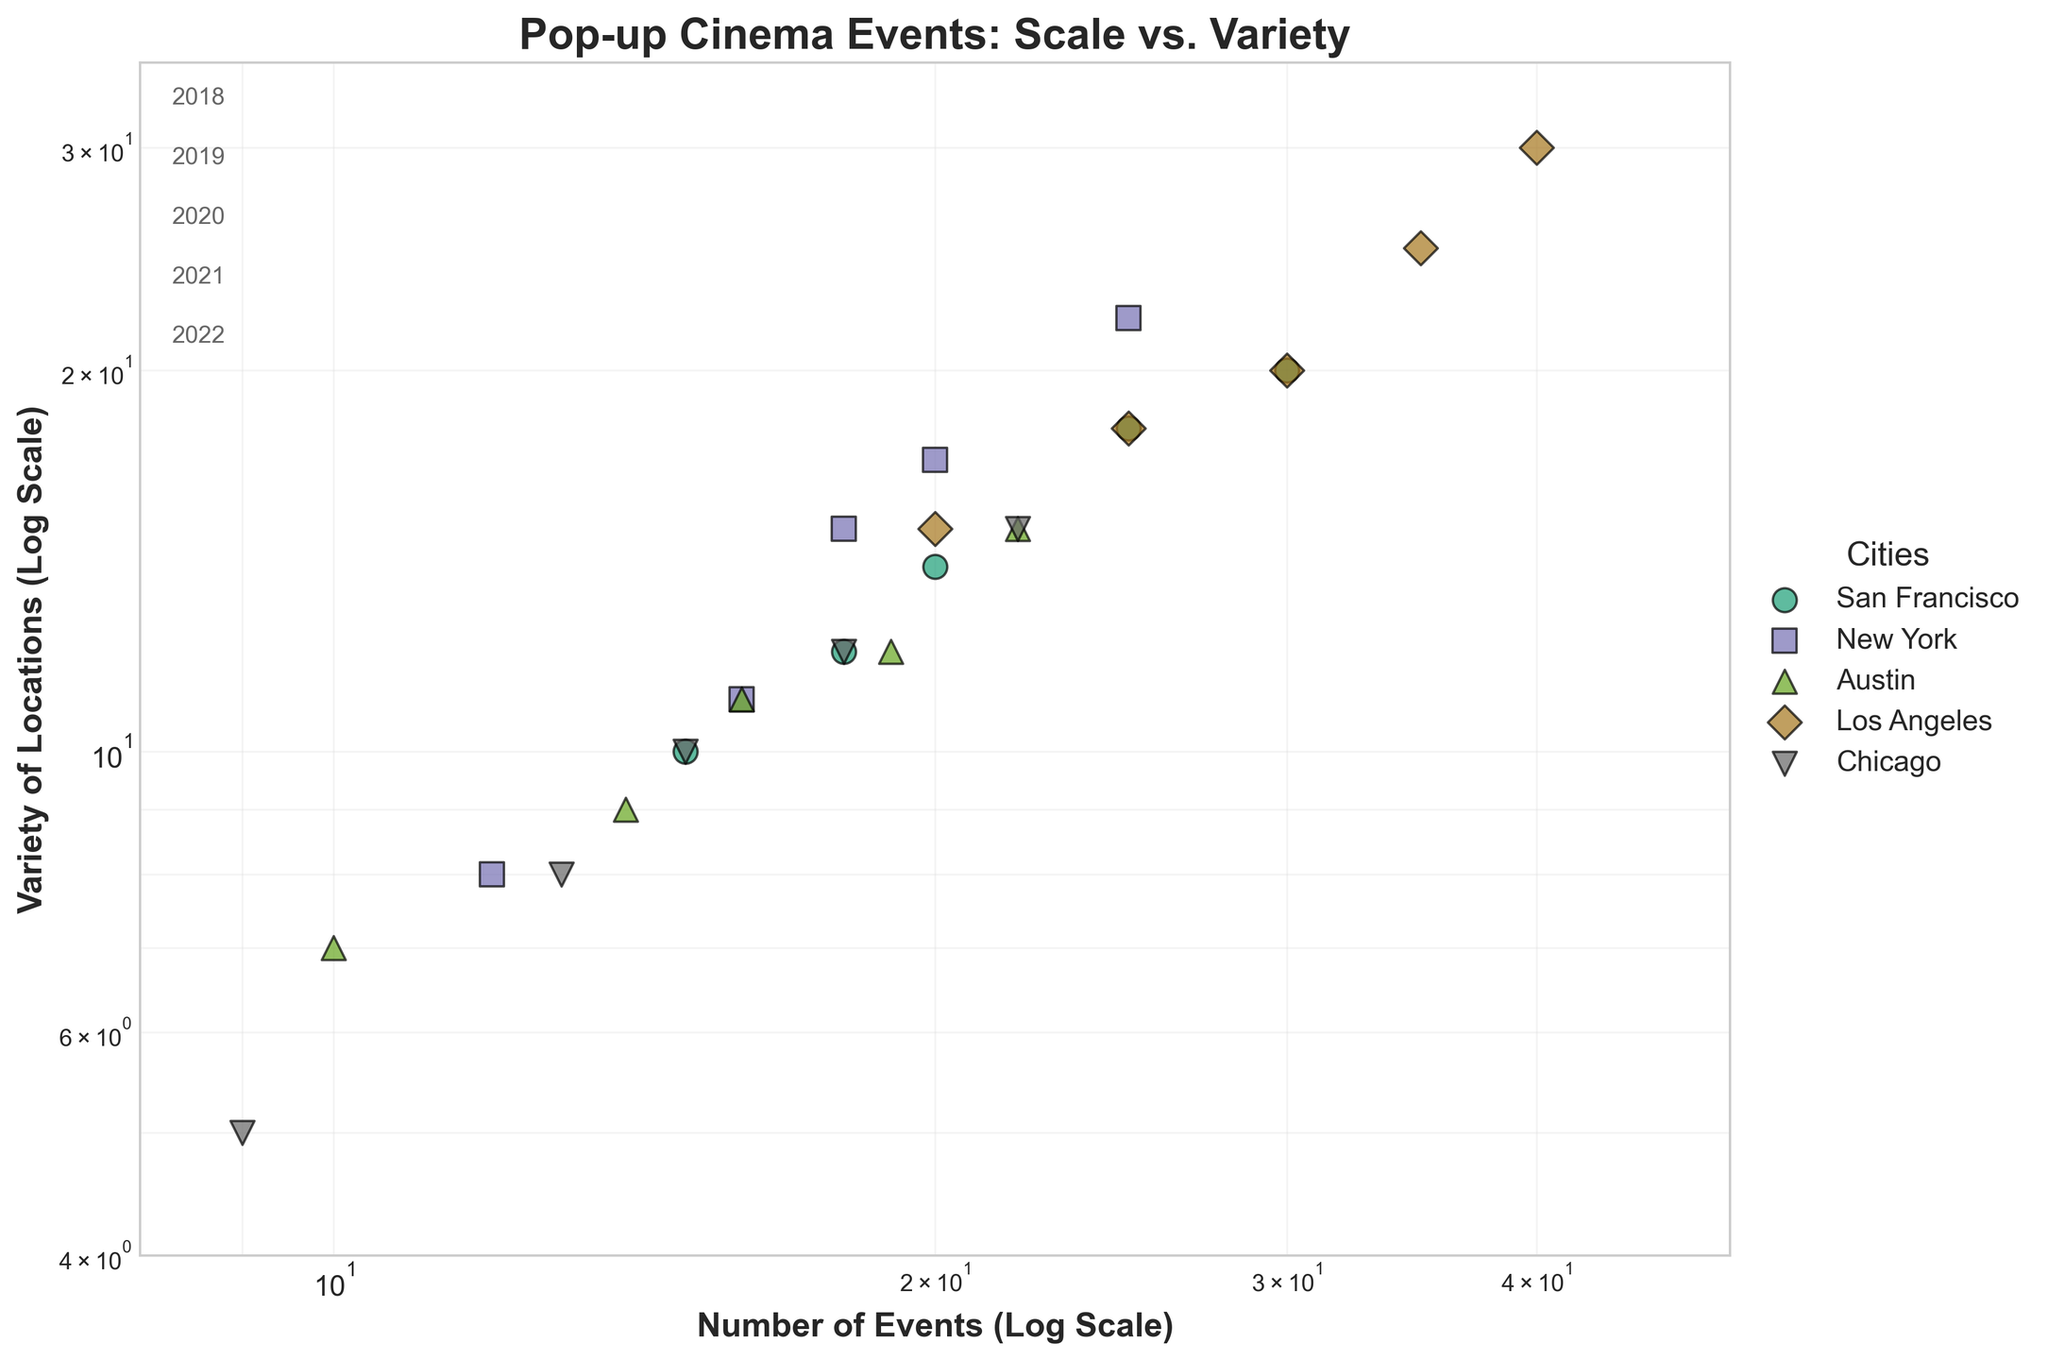what is the title of the plot? The title is located at the top of the plot. It provides an overview of the data visualized in the scatter plot.
Answer: Pop-up Cinema Events: Scale vs. Variety How many cities are represented in the plot? Each unique color and marker represent a different city, and the legend on the right shows the city's names. Count the different entries in the legend.
Answer: 5 Which city has the highest number of events in 2022? Look for the data point that represents 2022 for each city. Identify which city has the highest x-value (Number of Events) in 2022.
Answer: Los Angeles Which city had the least variety of locations used in 2018? Look for the data points that represent 2018 for each city. Identify which city has the lowest y-value (Variety of Locations) in 2018.
Answer: Chicago What is the relationship shown by the axes in the plot? The title of the axes indicates the relationship between the two quantities. One axis shows the Number of Events while the other shows the Variety of Locations used, both on a log scale.
Answer: Number of Events vs. Variety of Locations How does the variety of locations in Los Angeles compare from 2018 to 2022? Find the 2018 and 2022 data points for Los Angeles and compare their y-values (Variety of Locations). Note the increase or decrease.
Answer: Increased How did New York's number of events change from 2020 to 2022? Check the x-values (Number of Events) for New York in 2020 and 2022 and calculate the difference between them.
Answer: Increased by 7 Which city shows a consistent increase in both number of events and variety of locations every year? Identify which city's data points form a consistent upward trend in both x and y directions across all years.
Answer: Los Angeles What pattern can you observe about the number of events relative to the variety of locations used on a log scale? By examining the spread of the data points, note the general trend or pattern shown by the relationship between the number of events and variety of locations on a logarithmic scale.
Answer: Positive correlation Which city had the closest number of events to Austin in 2021? Compare the data points for 2021 and find the city closest to Austin's x-value (Number of Events).
Answer: New York 